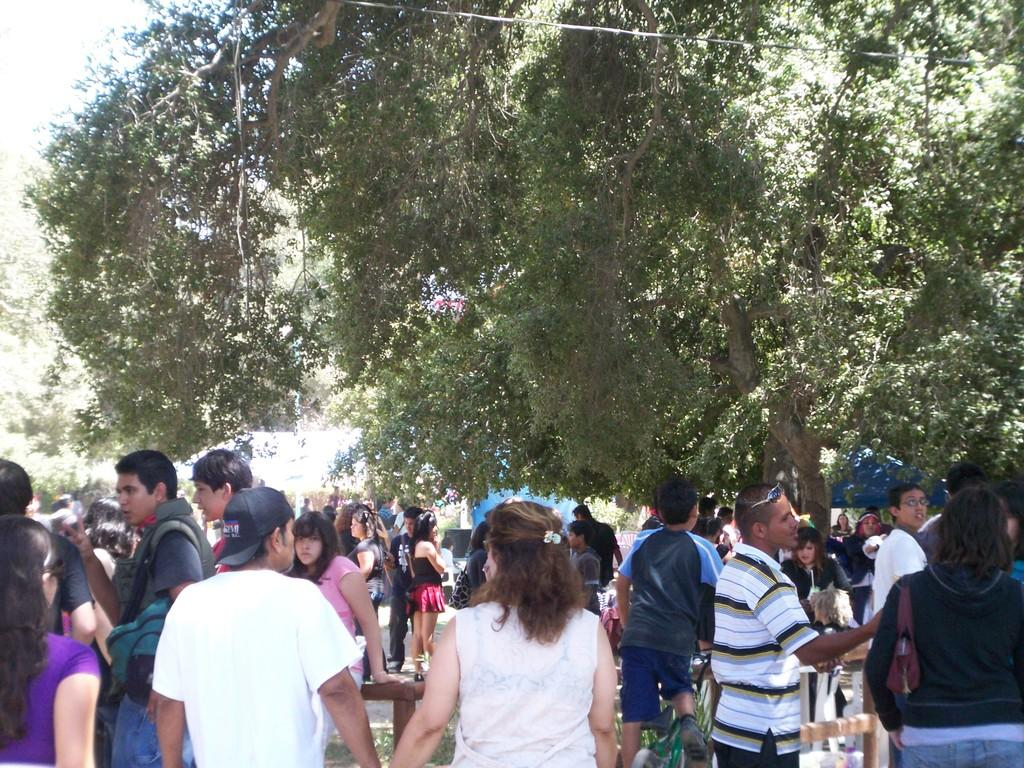What can be observed about the people in the image? There are people standing in the image, including men and women. What else is present in the image besides the people? There are trees in the image. What is the need for blood in the image? There is no mention of blood or any need for it in the image. 